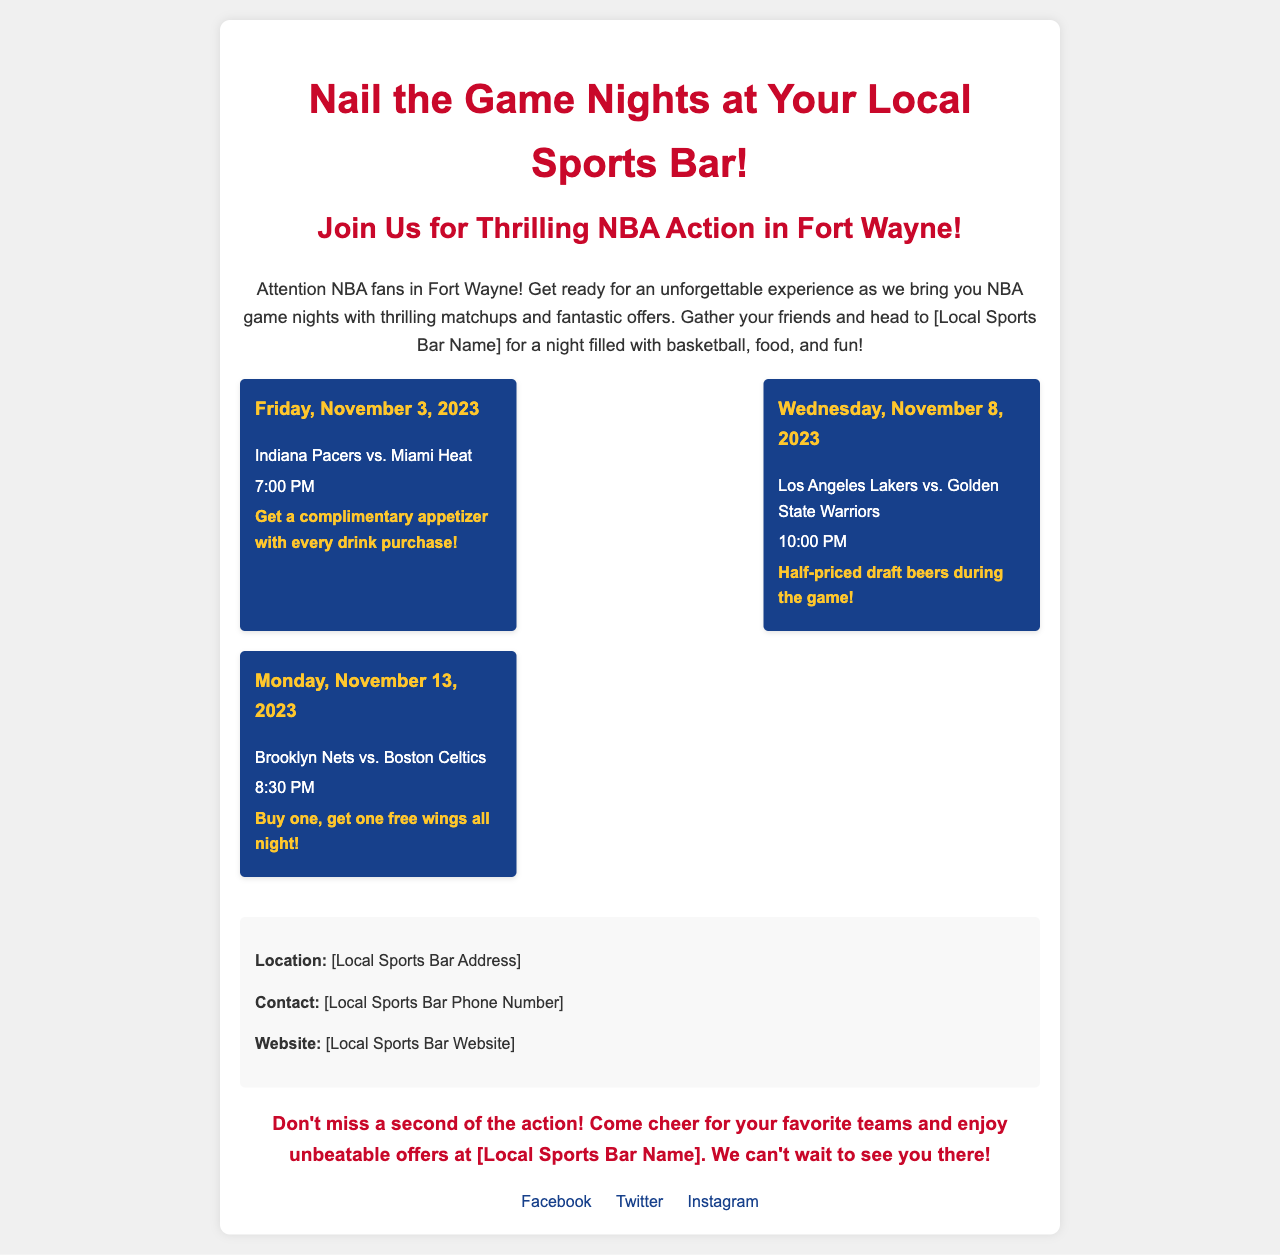What is the name of the local sports bar? The document mentions a placeholder for the local sports bar name, which should be filled in with the actual name.
Answer: [Local Sports Bar Name] What is the date of the first game night? The first game night date stated in the document is a specific event mentioned under game nights.
Answer: Friday, November 3, 2023 Which teams are playing on November 8, 2023? The document lists the teams involved in the game on that date under game nights.
Answer: Los Angeles Lakers vs. Golden State Warriors What time does the game on November 13, 2023, start? The document provides the start time for the game on November 13, 2023, as listed in the game night details.
Answer: 8:30 PM What special offer is available on game night for the Pacers vs. Heat game? The document specifies the special offer for that game, which encourages customers to make a purchase.
Answer: Get a complimentary appetizer with every drink purchase What is emphasized in the call to action? The call to action encourages fans to attend and enjoy special promotions during the games.
Answer: Don't miss a second of the action! What social media platforms are linked in the document? The document mentions specific social media platforms where fans can follow updates and offers from the bar.
Answer: Facebook, Twitter, Instagram How many game nights are mentioned in the document? The number of game nights listed can be counted from the sections provided in the document.
Answer: Three 